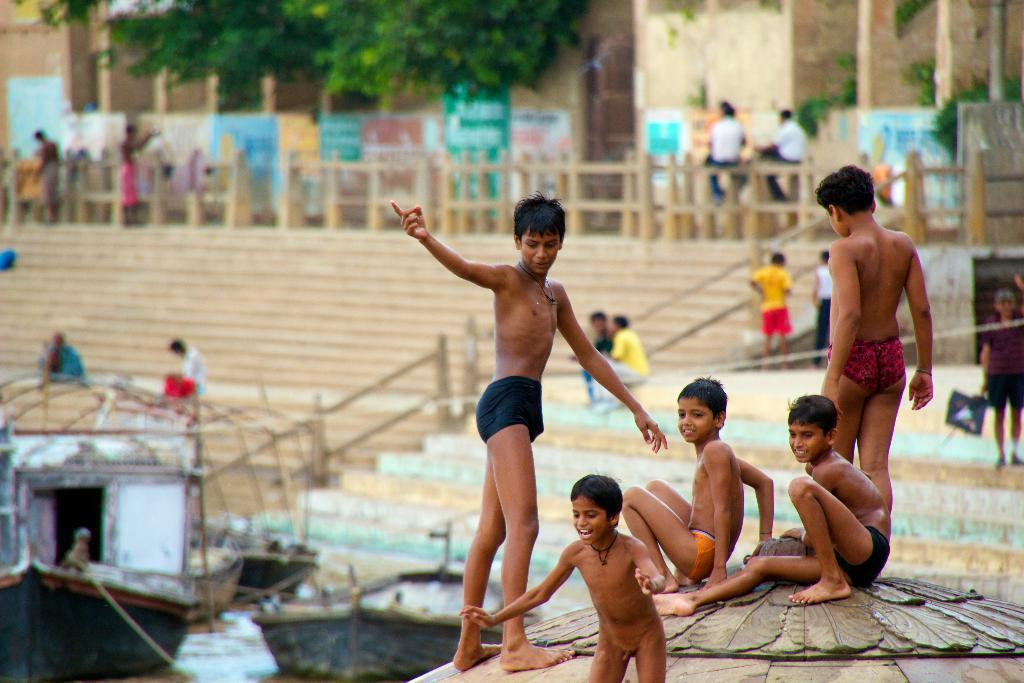What are the people in the image doing on the staircase? The people in the image are sitting and standing on the staircase. What can be seen in the background of the image? Buildings and trees are visible in the image. What is on the walls in the image? There are advertisements on the walls. What is in the water in the image? There are boards in the water. Can you see a woman kicking a ball in the image? There is no woman kicking a ball in the image. Is there a bridge visible in the image? There is no bridge present in the image. 